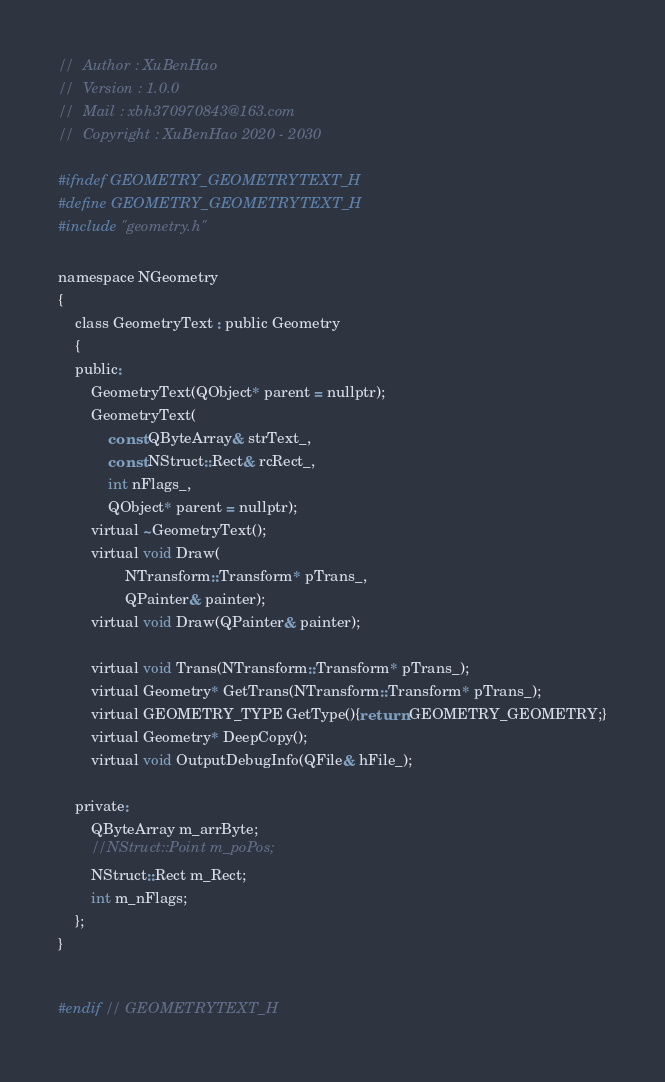Convert code to text. <code><loc_0><loc_0><loc_500><loc_500><_C_>//	Author : XuBenHao      
//	Version : 1.0.0                 
//	Mail : xbh370970843@163.com
//	Copyright : XuBenHao 2020 - 2030

#ifndef GEOMETRY_GEOMETRYTEXT_H
#define GEOMETRY_GEOMETRYTEXT_H
#include "geometry.h"

namespace NGeometry
{
    class GeometryText : public Geometry
    {
    public:
        GeometryText(QObject* parent = nullptr);
        GeometryText(
            const QByteArray& strText_,
            const NStruct::Rect& rcRect_,
            int nFlags_,
            QObject* parent = nullptr);
        virtual ~GeometryText();
        virtual void Draw(
                NTransform::Transform* pTrans_, 
                QPainter& painter);
        virtual void Draw(QPainter& painter);

        virtual void Trans(NTransform::Transform* pTrans_);
        virtual Geometry* GetTrans(NTransform::Transform* pTrans_);
        virtual GEOMETRY_TYPE GetType(){return GEOMETRY_GEOMETRY;}
        virtual Geometry* DeepCopy();
        virtual void OutputDebugInfo(QFile& hFile_);

    private:
        QByteArray m_arrByte;
        //NStruct::Point m_poPos;
        NStruct::Rect m_Rect;
        int m_nFlags;
    };
}


#endif // GEOMETRYTEXT_H
</code> 